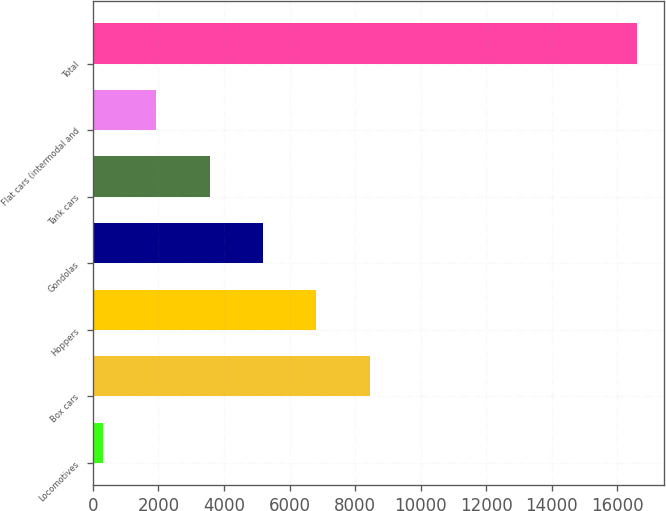Convert chart to OTSL. <chart><loc_0><loc_0><loc_500><loc_500><bar_chart><fcel>Locomotives<fcel>Box cars<fcel>Hoppers<fcel>Gondolas<fcel>Tank cars<fcel>Flat cars (intermodal and<fcel>Total<nl><fcel>295<fcel>8451<fcel>6819.8<fcel>5188.6<fcel>3557.4<fcel>1926.2<fcel>16607<nl></chart> 